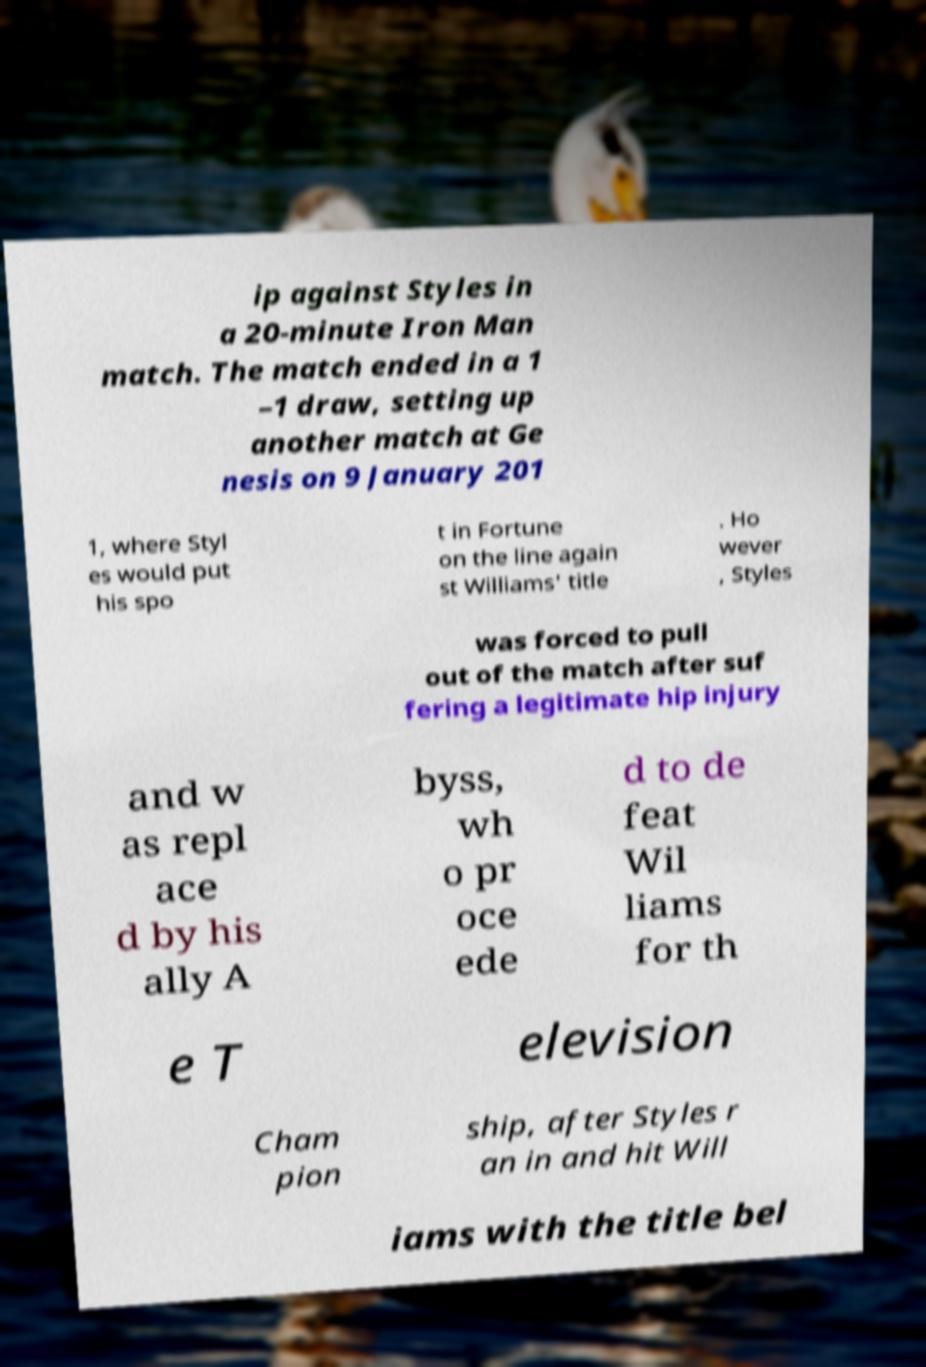For documentation purposes, I need the text within this image transcribed. Could you provide that? ip against Styles in a 20-minute Iron Man match. The match ended in a 1 –1 draw, setting up another match at Ge nesis on 9 January 201 1, where Styl es would put his spo t in Fortune on the line again st Williams' title . Ho wever , Styles was forced to pull out of the match after suf fering a legitimate hip injury and w as repl ace d by his ally A byss, wh o pr oce ede d to de feat Wil liams for th e T elevision Cham pion ship, after Styles r an in and hit Will iams with the title bel 